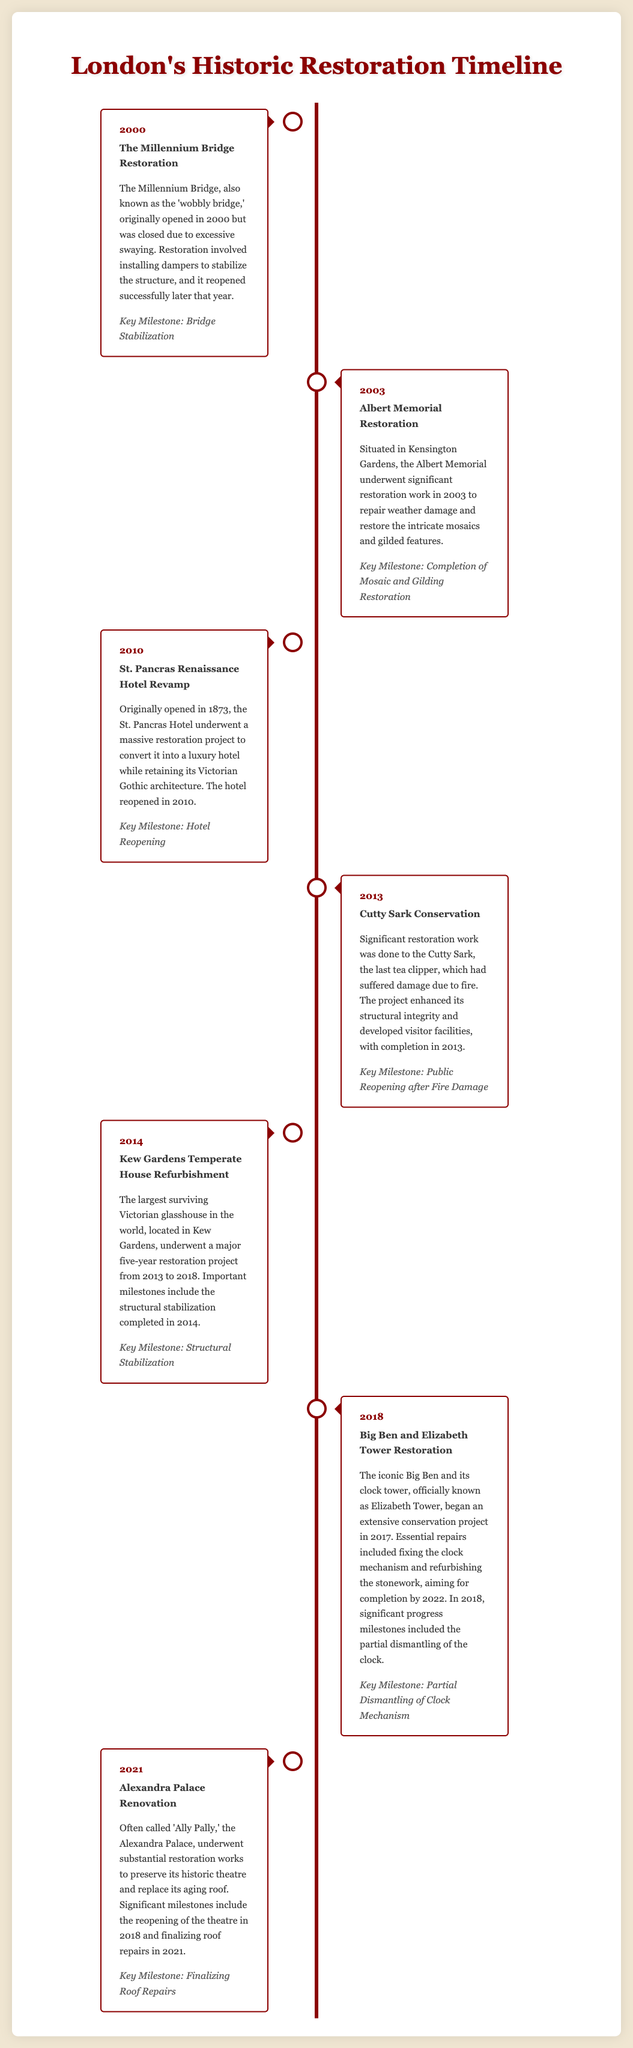What was the name of the restoration project in 2000? The project in 2000 was known as The Millennium Bridge Restoration.
Answer: The Millennium Bridge Restoration What year did the Albert Memorial undergo restoration? The Albert Memorial restoration took place in 2003.
Answer: 2003 What key milestone was achieved during the Cutty Sark Conservation in 2013? The key milestone for the Cutty Sark Conservation in 2013 was the public reopening after fire damage.
Answer: Public Reopening after Fire Damage How many years did the Kew Gardens Temperate House project span from start to finish? The Kew Gardens Temperate House project spanned five years, from 2013 to 2018.
Answer: Five years Which historic site had its theatre reopened in 2018? The site with a theater that reopened in 2018 was Alexandra Palace.
Answer: Alexandra Palace What significant restoration work was done to Big Ben in 2018? In 2018, a significant restoration work on Big Ben included the partial dismantling of the clock mechanism.
Answer: Partial Dismantling of Clock Mechanism In what year was the St. Pancras Renaissance Hotel reopened? The St. Pancras Renaissance Hotel reopened in the year 2010.
Answer: 2010 What type of architecture does the St. Pancras Hotel retain? The St. Pancras Hotel retains its Victorian Gothic architecture.
Answer: Victorian Gothic architecture 